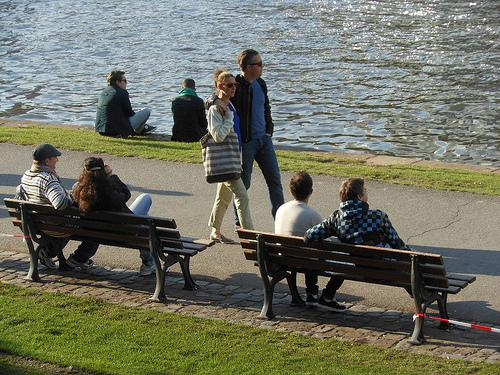Question: who is walking?
Choices:
A. A man and woman.
B. A boy and girl.
C. Two girls.
D. Three men.
Answer with the letter. Answer: A Question: how many people are on benches?
Choices:
A. Four.
B. Five.
C. Six.
D. Seven.
Answer with the letter. Answer: A Question: who are the people sitting who are not on the benches?
Choices:
A. On chairs.
B. On the grass.
C. On boulders.
D. On blankets.
Answer with the letter. Answer: B 